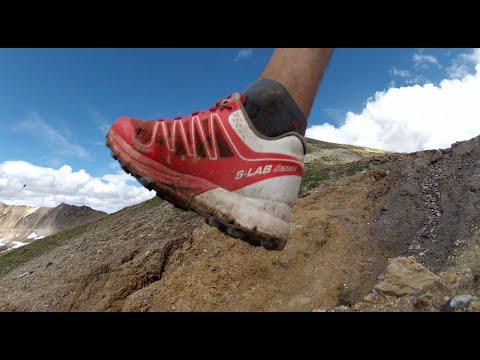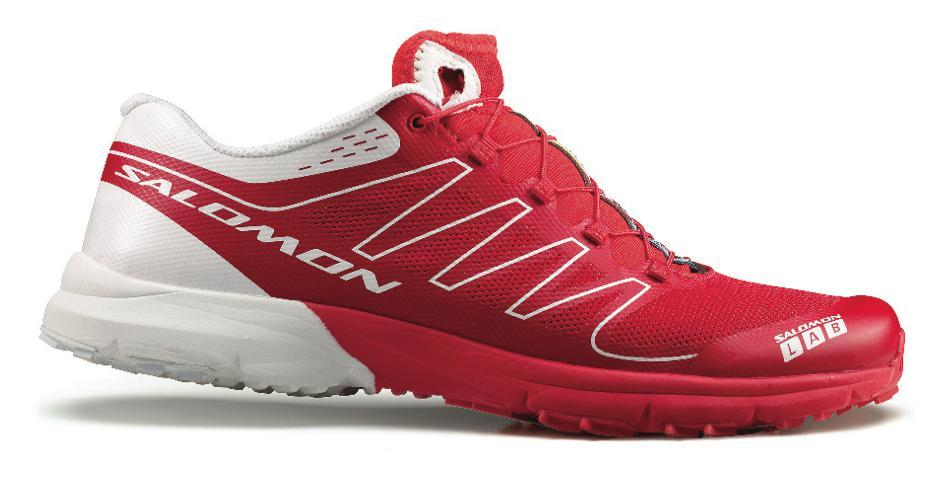The first image is the image on the left, the second image is the image on the right. For the images displayed, is the sentence "All of the shoes in the images are being displayed indoors." factually correct? Answer yes or no. No. The first image is the image on the left, the second image is the image on the right. For the images displayed, is the sentence "Each image contains one sneaker that includes red color, and the shoes in the left and right images face different directions." factually correct? Answer yes or no. Yes. 